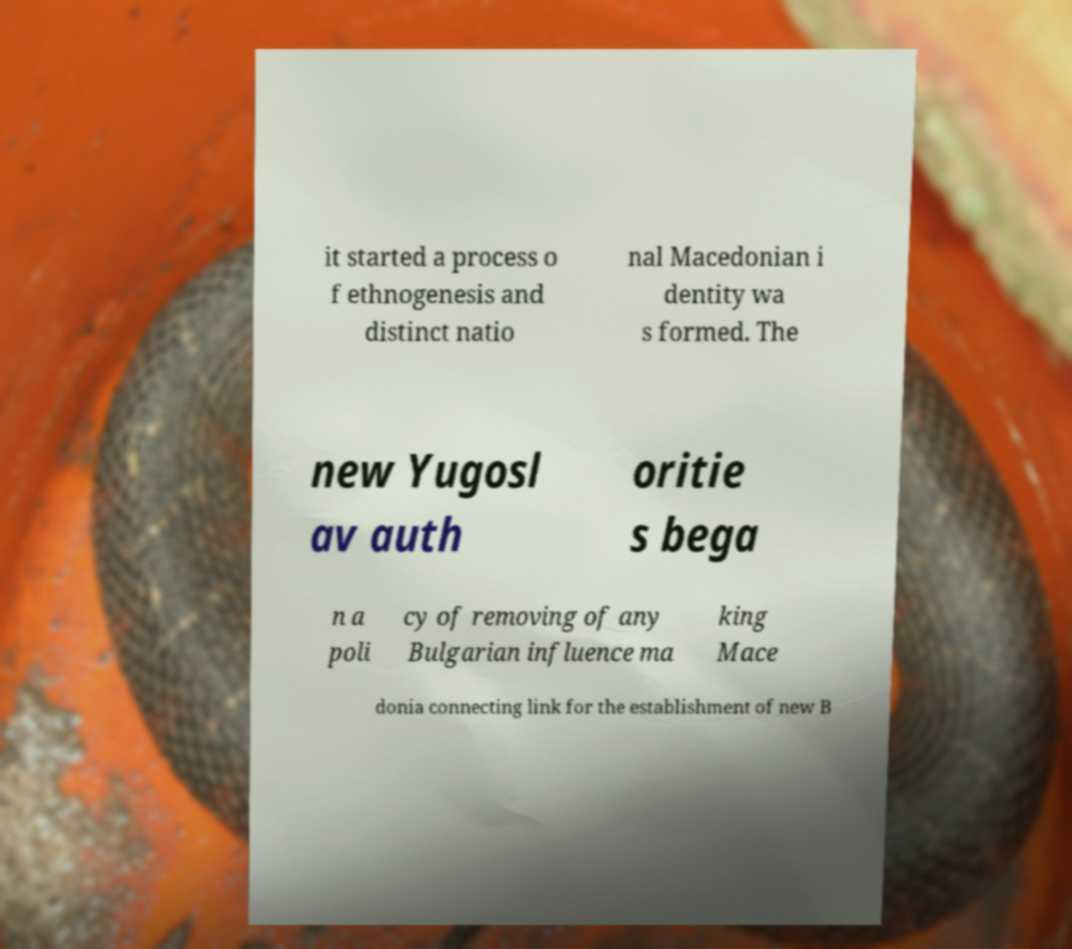I need the written content from this picture converted into text. Can you do that? it started a process o f ethnogenesis and distinct natio nal Macedonian i dentity wa s formed. The new Yugosl av auth oritie s bega n a poli cy of removing of any Bulgarian influence ma king Mace donia connecting link for the establishment of new B 